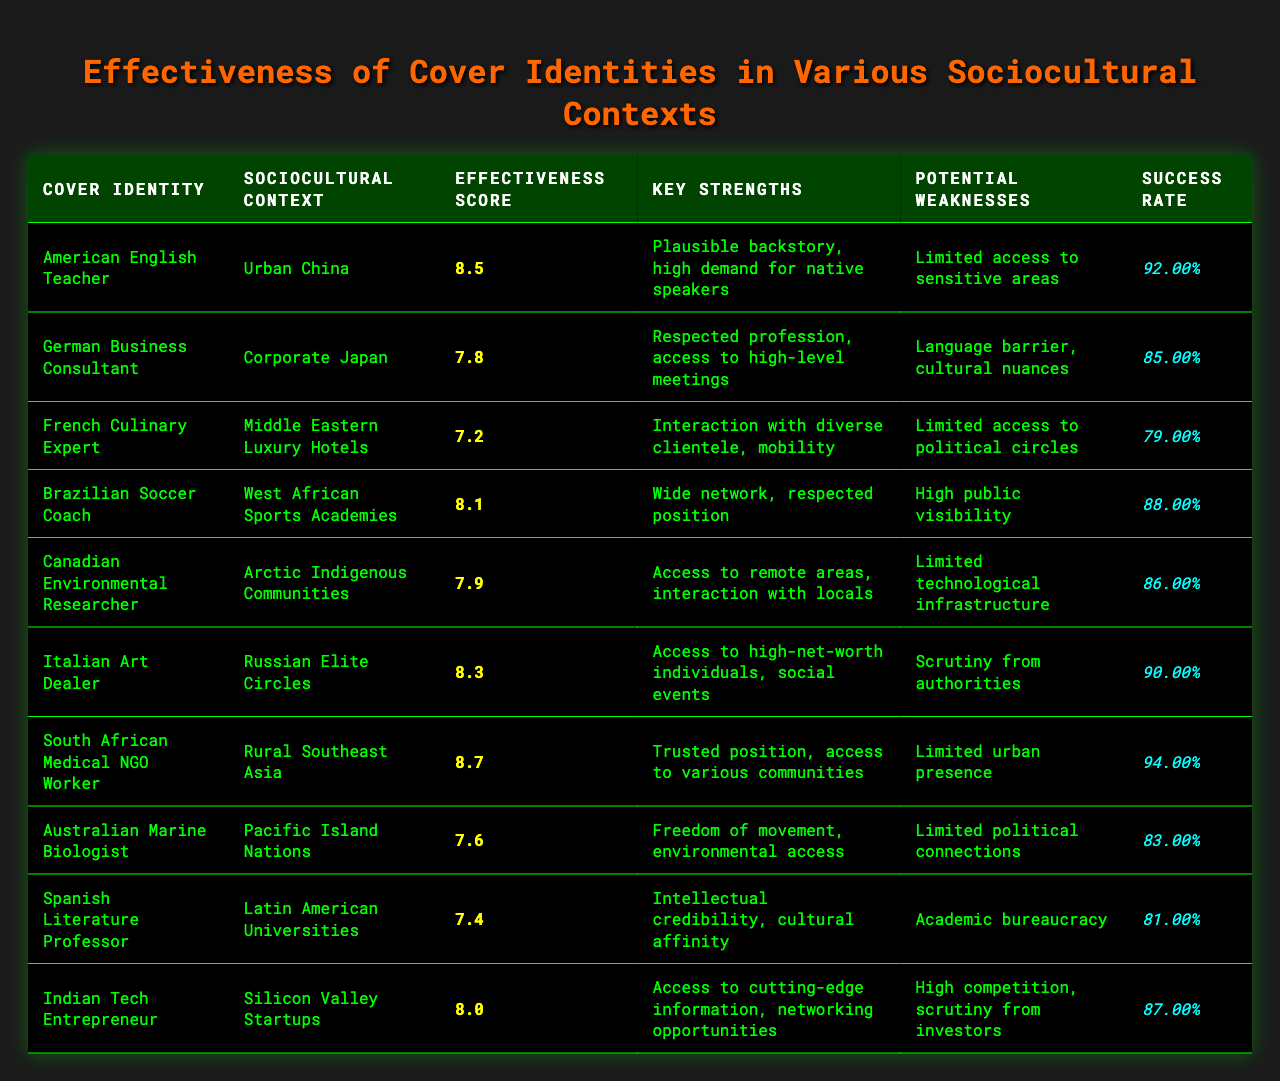What is the effectiveness score of the South African Medical NGO Worker in Rural Southeast Asia? The table directly shows the effectiveness score for the South African Medical NGO Worker listed under Rural Southeast Asia as 8.7.
Answer: 8.7 How many cover identities have an effectiveness score above 8.0? By scanning the table, the cover identities with effectiveness scores above 8.0 are: American English Teacher (8.5), Brazilian Soccer Coach (8.1), Italian Art Dealer (8.3), and South African Medical NGO Worker (8.7). This amounts to a total of 4 identities.
Answer: 4 What is the key strength of the Canadian Environmental Researcher? The table specifies the key strength of the Canadian Environmental Researcher as "Access to remote areas, interaction with locals."
Answer: Access to remote areas, interaction with locals Is the success rate for the Brazilian Soccer Coach higher than 0.85? The table indicates that the success rate for the Brazilian Soccer Coach is 0.88, which is greater than 0.85. Therefore, the fact is true.
Answer: Yes Which cover identity has the highest success rate and what is it? To find the highest success rate, we look at the success rates listed. The South African Medical NGO Worker has a success rate of 0.94, which is the highest among all listed identities.
Answer: South African Medical NGO Worker, 0.94 What is the average effectiveness score of cover identities in urban contexts? The only cover identity listed in an urban context is the American English Teacher with an effectiveness score of 8.5, making the average effectiveness score 8.5 since there's only one score.
Answer: 8.5 Does any cover identity have a limited access to political circles? The French Culinary Expert's potential weakness includes "Limited access to political circles," confirming this fact is accurate.
Answer: Yes What is the difference in effectiveness scores between the South African Medical NGO Worker and the Spanish Literature Professor? The effectiveness score of the South African Medical NGO Worker is 8.7 and for the Spanish Literature Professor, it is 7.4. The difference is calculated as 8.7 - 7.4 = 1.3.
Answer: 1.3 Which cover identity in Latin American Universities has the lowest effectiveness score? The Spanish Literature Professor in Latin American Universities has the lowest effectiveness score at 7.4, according to the table.
Answer: Spanish Literature Professor, 7.4 How do the effectiveness scores of the German Business Consultant and Indian Tech Entrepreneur compare? The effectiveness score of the German Business Consultant is 7.8 and that of the Indian Tech Entrepreneur is 8.0. Since 8.0 is higher than 7.8, the Indian Tech Entrepreneur has a higher effectiveness score.
Answer: Indian Tech Entrepreneur is higher Which cover identity has the potential weakness of limited access to sensitive areas? The American English Teacher has a potential weakness listed as "Limited access to sensitive areas" in the table.
Answer: American English Teacher 